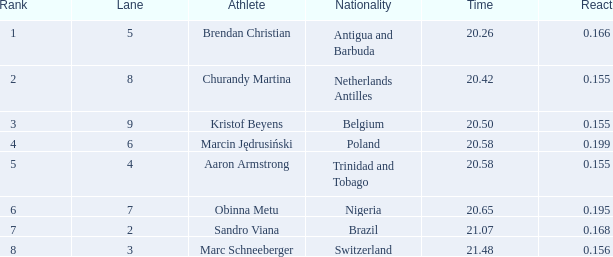In which lane does someone from trinidad and tobago have a time greater than 20.5? 4.0. 